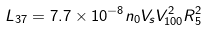<formula> <loc_0><loc_0><loc_500><loc_500>L _ { 3 7 } = 7 . 7 \times 1 0 ^ { - 8 } n _ { 0 } V _ { s } V _ { 1 0 0 } ^ { 2 } R _ { 5 } ^ { 2 }</formula> 